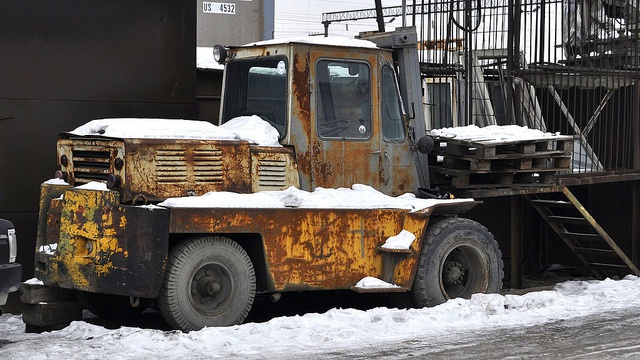Describe the objects in this image and their specific colors. I can see a truck in black, gray, white, and maroon tones in this image. 